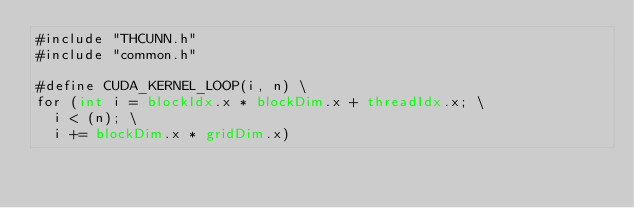Convert code to text. <code><loc_0><loc_0><loc_500><loc_500><_Cuda_>#include "THCUNN.h"
#include "common.h"

#define CUDA_KERNEL_LOOP(i, n) \
for (int i = blockIdx.x * blockDim.x + threadIdx.x; \
  i < (n); \
  i += blockDim.x * gridDim.x)
</code> 